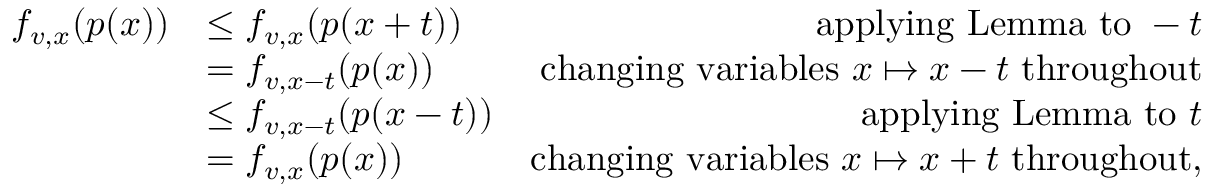<formula> <loc_0><loc_0><loc_500><loc_500>\begin{array} { r l r } { f _ { v , x } ( p ( x ) ) } & { \leq f _ { v , x } ( p ( x + t ) ) } & { a p p l y i n g L e m m a t o - t } \\ & { = f _ { v , x - t } ( p ( x ) ) } & { c h a n g i n g v a r i a b l e s x \mapsto x - t t h r o u g h o u t } \\ & { \leq f _ { v , x - t } ( p ( x - t ) ) } & { a p p l y i n g L e m m a t o t } \\ & { = f _ { v , x } ( p ( x ) ) } & { c h a n g i n g v a r i a b l e s x \mapsto x + t t h r o u g h o u t , } \end{array}</formula> 